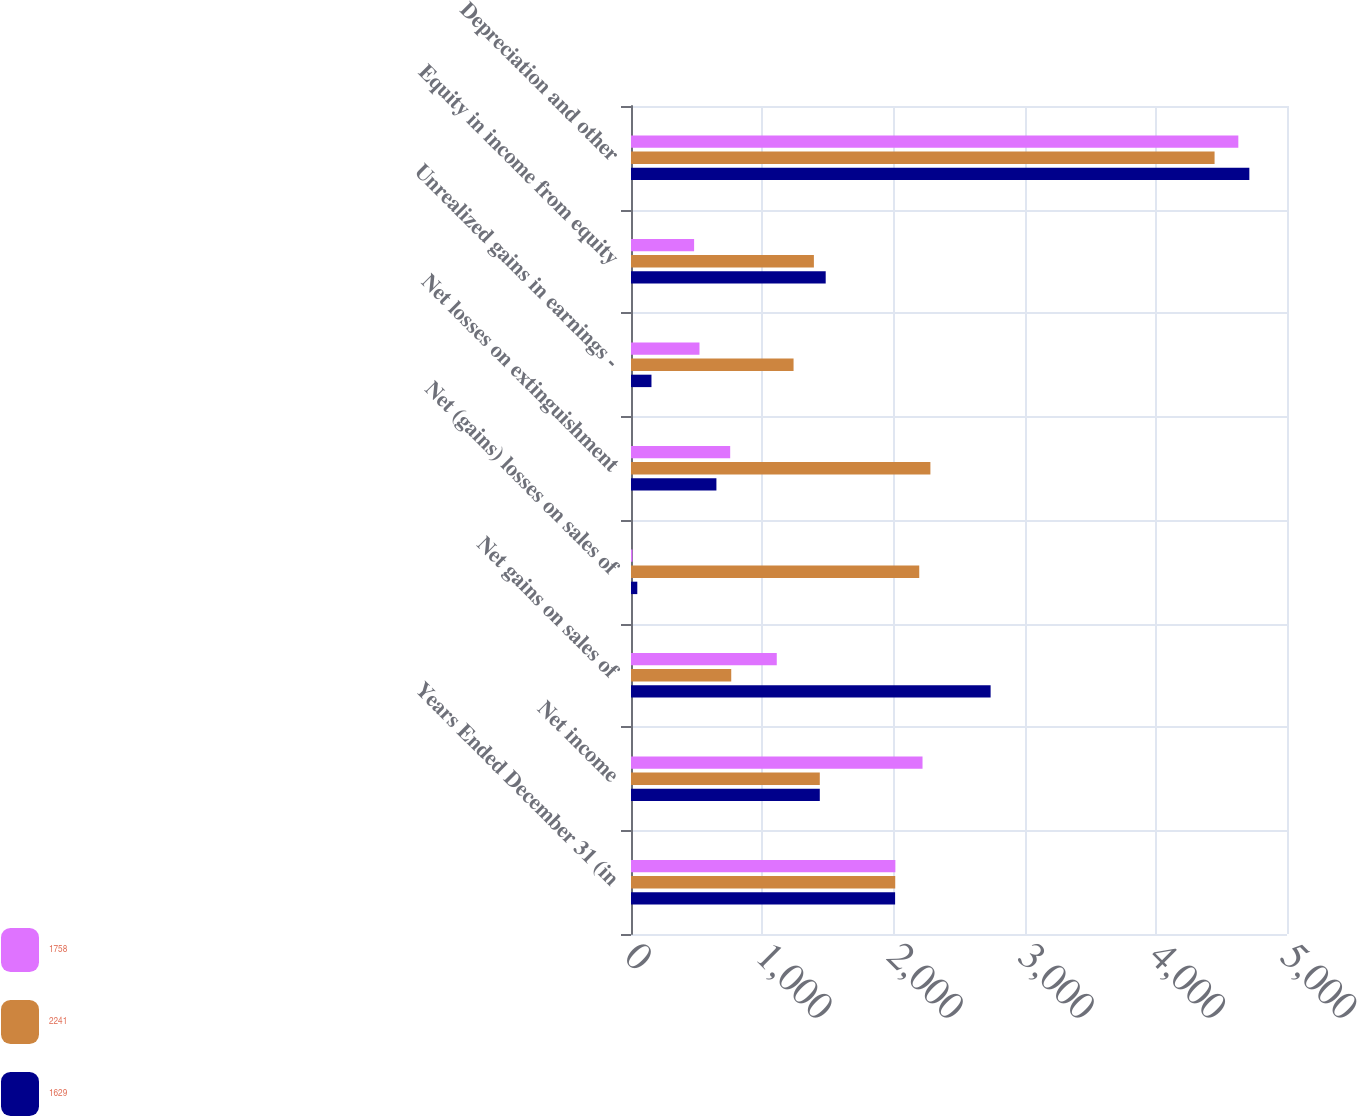Convert chart to OTSL. <chart><loc_0><loc_0><loc_500><loc_500><stacked_bar_chart><ecel><fcel>Years Ended December 31 (in<fcel>Net income<fcel>Net gains on sales of<fcel>Net (gains) losses on sales of<fcel>Net losses on extinguishment<fcel>Unrealized gains in earnings -<fcel>Equity in income from equity<fcel>Depreciation and other<nl><fcel>1758<fcel>2015<fcel>2222<fcel>1111<fcel>11<fcel>756<fcel>522<fcel>481<fcel>4629<nl><fcel>2241<fcel>2014<fcel>1439<fcel>764<fcel>2197<fcel>2282<fcel>1239<fcel>1394<fcel>4448<nl><fcel>1629<fcel>2013<fcel>1439<fcel>2741<fcel>48<fcel>651<fcel>156<fcel>1484<fcel>4713<nl></chart> 